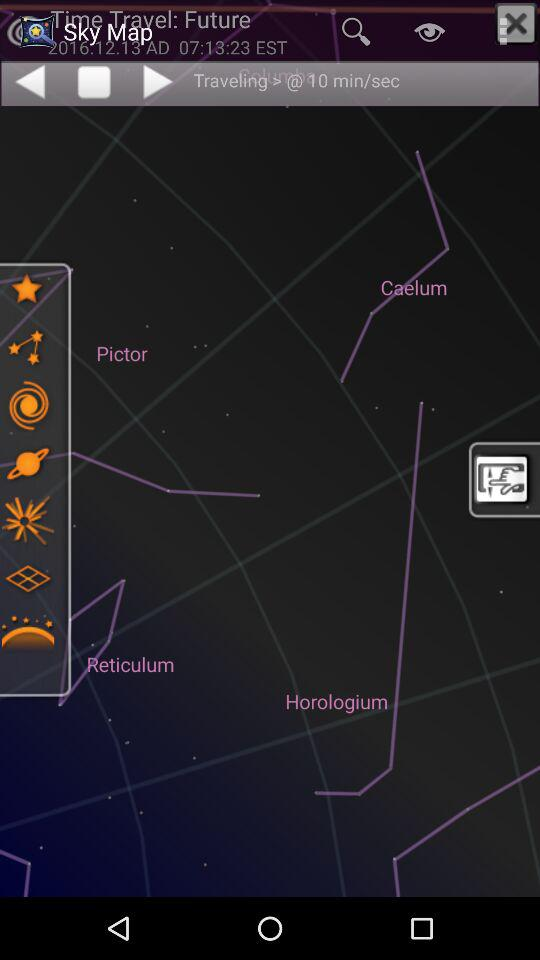What is the traveling time in min/sec? The traveling time in min/sec is 10. 